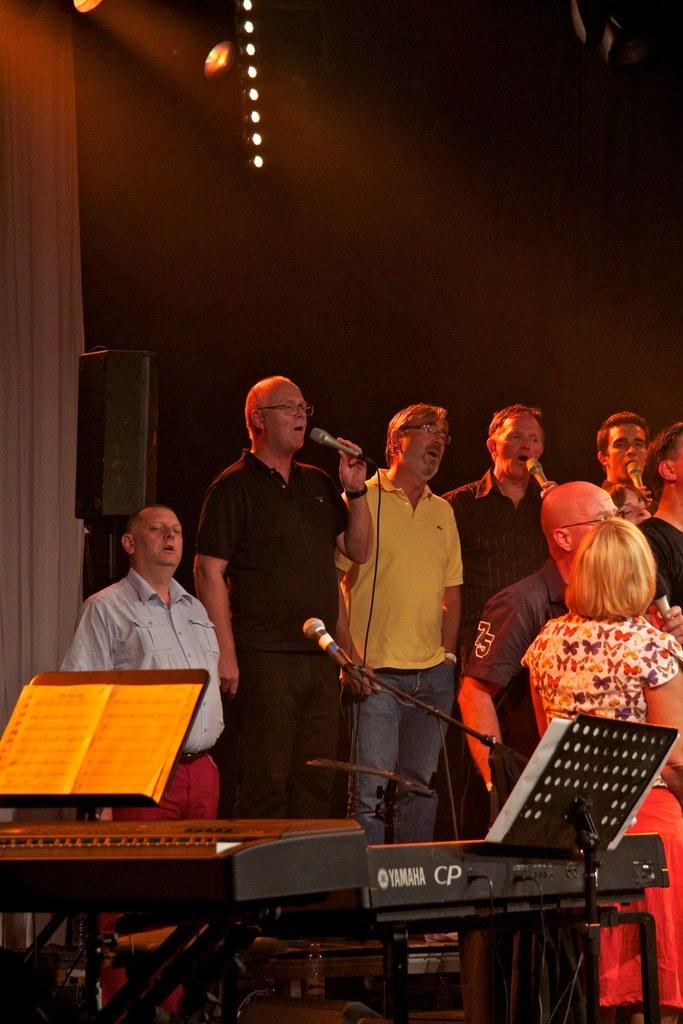<image>
Offer a succinct explanation of the picture presented. a Yamaha piano in front of a man with a mic 